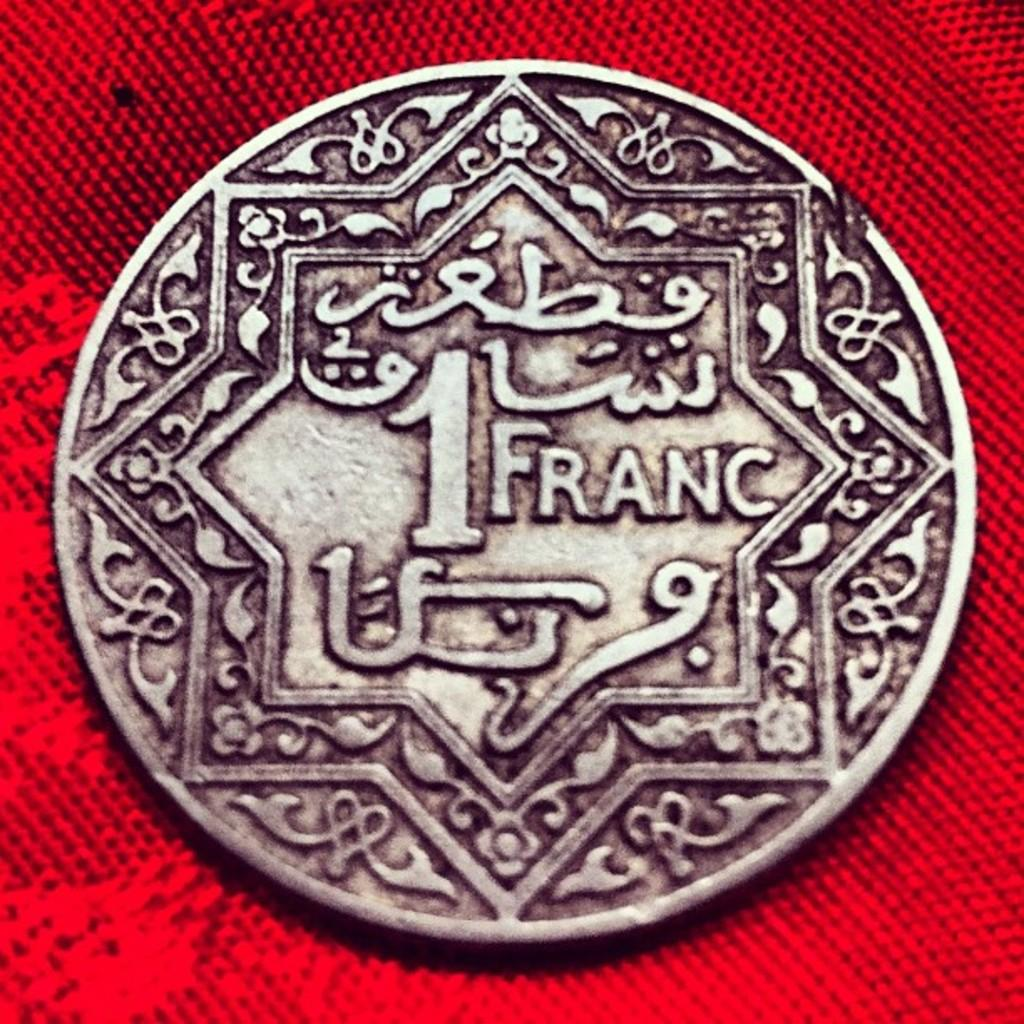<image>
Relay a brief, clear account of the picture shown. The old silver coin shown is 1Franc from the french currency. 